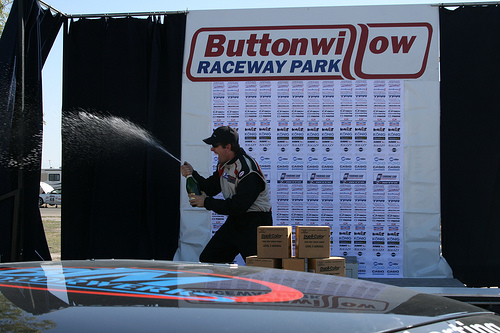<image>
Can you confirm if the man is to the right of the bottle? No. The man is not to the right of the bottle. The horizontal positioning shows a different relationship. 